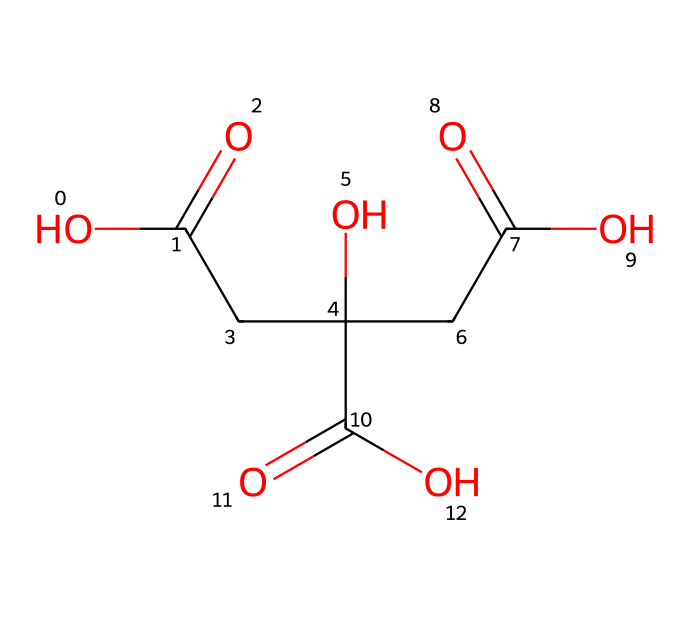What is the name of this chemical? The SMILES representation corresponds to citric acid, which is a known organic acid commonly found in various fruits, especially citrus fruits. The structure reveals its functional groups as carboxylic acids, which is characteristic of citric acid.
Answer: citric acid How many carboxylic acid groups are present in this molecule? By analyzing the structure, we can identify three carboxylic acid groups based on the presence of three -COOH groups within the molecular framework of citric acid.
Answer: three What is the molecular formula of citric acid? From the SMILES notation, we can deduce the molecular formula by counting the number of carbon (C), hydrogen (H), and oxygen (O) atoms. In this case, there are six carbon atoms, eight hydrogen atoms, and seven oxygen atoms, leading us to the formula C6H8O7.
Answer: C6H8O7 What is the total number of hydroxyl groups in citric acid? The SMILES representation shows one hydroxyl group (-OH) attached to the carbon chain, which can be confirmed by recognizing the -OH group as a part of its structure indicating a true hydroxyl functional group.
Answer: one Is citric acid a strong or weak acid? Citric acid is categorized as a weak acid because it does not completely dissociate in water. This can be inferred from its structure, which features three carboxylic acid groups that partially donate protons when dissolved, rather than fully ionizing.
Answer: weak What type of compound is citric acid? Citric acid is classified as an organic acid due to its carbon-based structure and the presence of multiple carboxylic acid functional groups. This classification can be made by examining the functional groups present in the molecular structure.
Answer: organic acid 